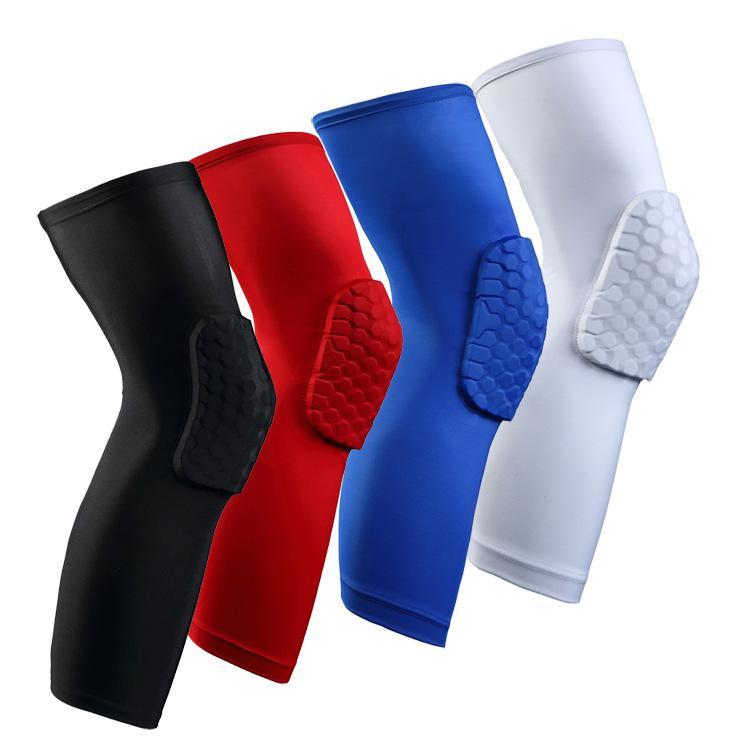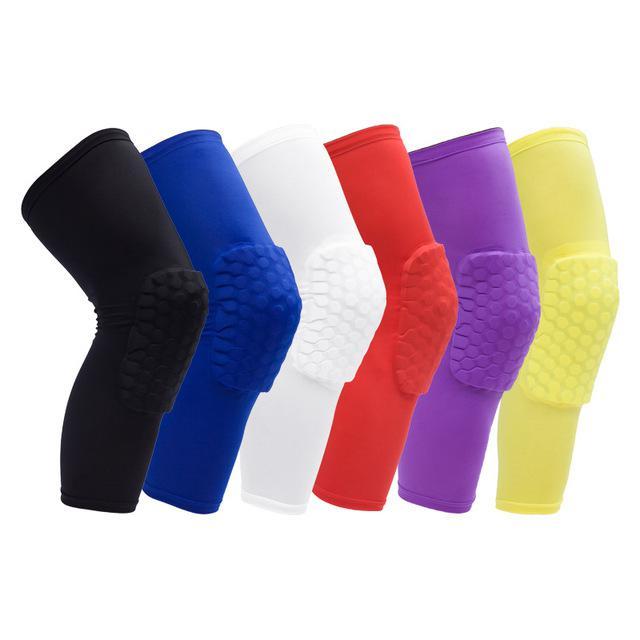The first image is the image on the left, the second image is the image on the right. Considering the images on both sides, is "Eight compression socks with knee pads are visible." valid? Answer yes or no. No. The first image is the image on the left, the second image is the image on the right. Assess this claim about the two images: "The right image shows 4 knee guards facing to the right.". Correct or not? Answer yes or no. No. 